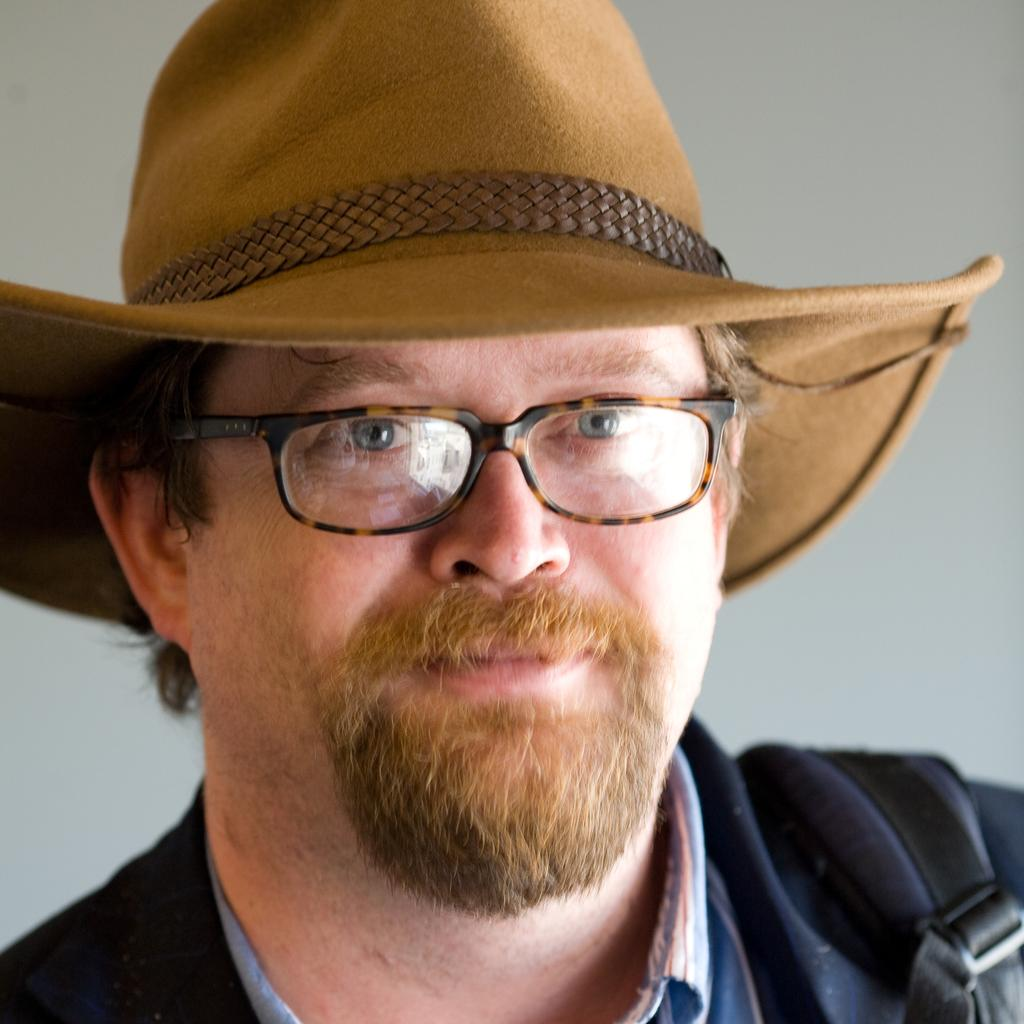Who is present in the image? There is a man in the image. What accessories is the man wearing? The man is wearing spectacles and a hat. What is the color of the background in the image? The background in the image is white. Absurd Question/Answer: Is the man's chain visible in the image? There is no mention of a chain in the provided facts, so we cannot determine if the man is wearing one. Therefore, we can ask an absurd question about the chain to highlight this point. Is the man feeling hot in the image? There is no information about the man's temperature or the weather in the provided facts, so we cannot determine if he is feeling hot. Therefore, we can ask an absurd question about the man feeling hot to highlight this point. 